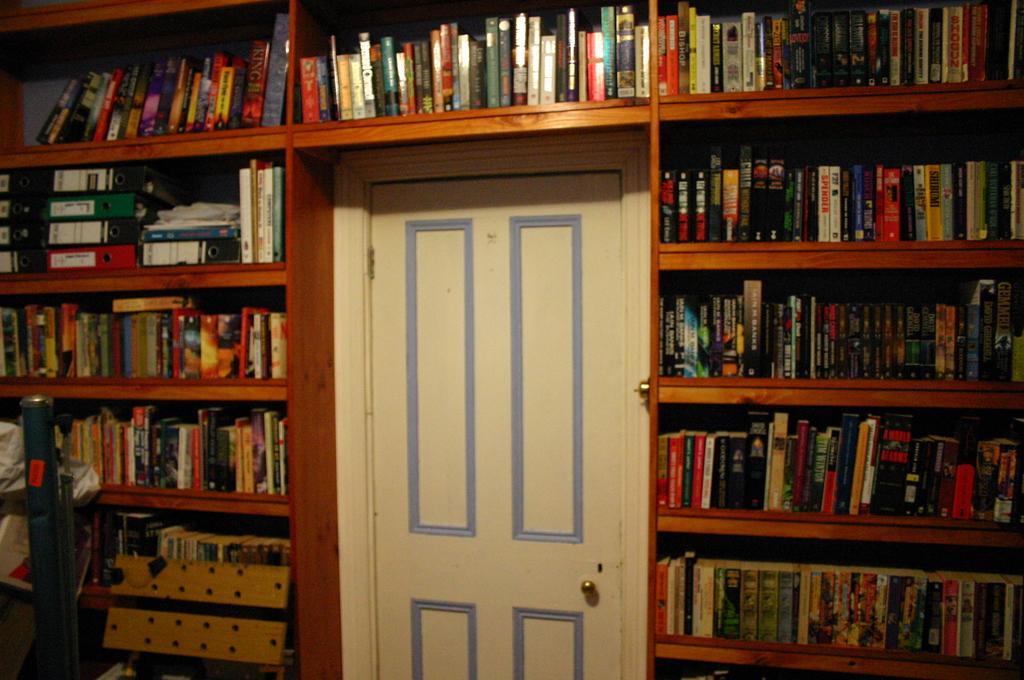Describe this image in one or two sentences. In this picture I can see there are some books in the book shelf and there is a door here. It is in white color. 